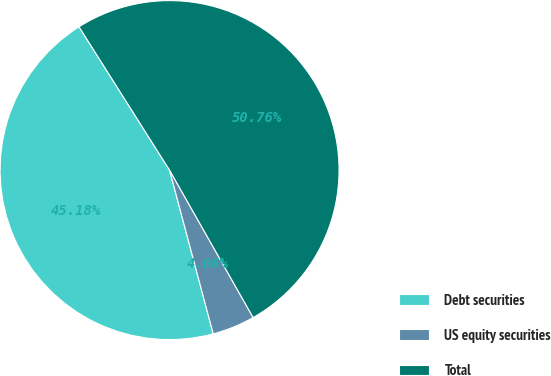Convert chart to OTSL. <chart><loc_0><loc_0><loc_500><loc_500><pie_chart><fcel>Debt securities<fcel>US equity securities<fcel>Total<nl><fcel>45.18%<fcel>4.06%<fcel>50.76%<nl></chart> 